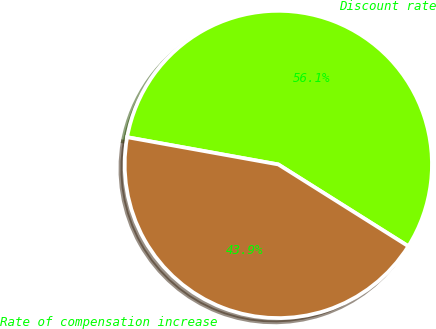<chart> <loc_0><loc_0><loc_500><loc_500><pie_chart><fcel>Discount rate<fcel>Rate of compensation increase<nl><fcel>56.1%<fcel>43.9%<nl></chart> 